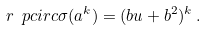Convert formula to latex. <formula><loc_0><loc_0><loc_500><loc_500>r \ p c i r c \sigma ( a ^ { k } ) = ( b u + b ^ { 2 } ) ^ { k } \, .</formula> 